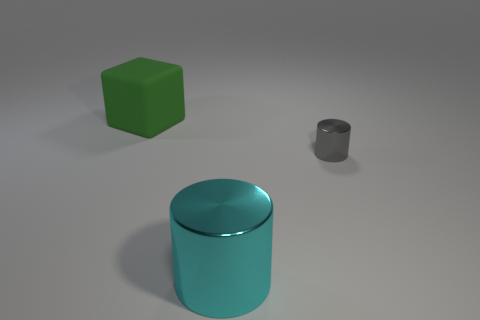What is the color of the big thing right of the big green cube? cyan 